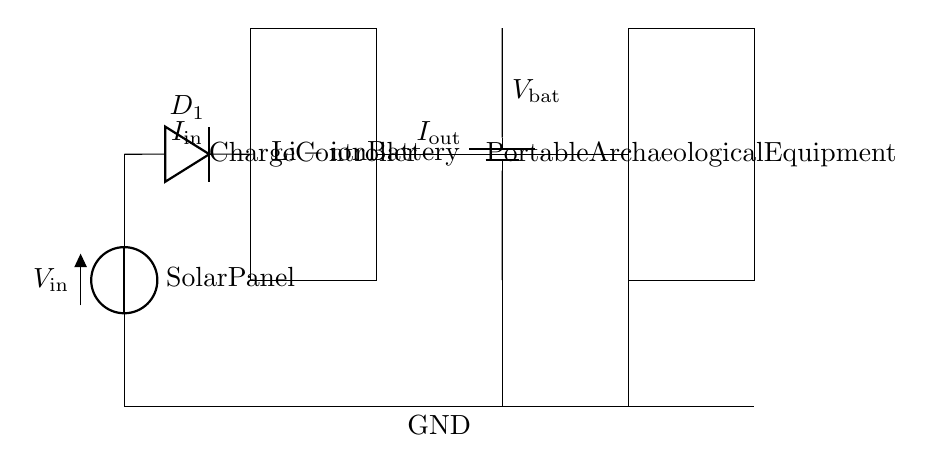What is the function of the solar panel in this circuit? The solar panel serves as the primary energy source, converting sunlight into electrical energy, indicated by the voltage source symbol labeled as Solar Panel.
Answer: Solar energy source What component prevents reverse current flow in the circuit? The blocking diode, labeled as D1, is positioned next to the solar panel, preventing current from flowing back into the solar panel when it is not generating power.
Answer: Blocking diode What type of battery is used in the circuit? The circuit diagram specifically labels the battery as a lithium-ion battery, which is commonly used for portable electronic devices due to its lightweight and efficient energy storage capabilities.
Answer: Lithium-ion battery What does the charge controller do in this circuit? The charge controller regulates voltage and current from the solar panel to the battery, ensuring safe charging while preventing overcharging or damage to the battery. It is represented by the rectangular block labeled Charge Controller.
Answer: Regulate charging What is the output voltage of the charge controller? The output current of the charge controller is indicated by the label Iout. Without specific values shown in the diagram, it is commonly designed to provide a steady voltage suitable for charging the battery and powering the load.
Answer: Not specified What is the load represented in the circuit? The load in this circuit is represented by the rectangle labeled Portable Archaeological Equipment, indicating that the circuit is designed to power devices used in field research.
Answer: Portable Archaeological Equipment 